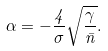Convert formula to latex. <formula><loc_0><loc_0><loc_500><loc_500>\alpha = - \frac { 4 } { \sigma } \sqrt { \frac { \gamma } { \bar { n } } } .</formula> 